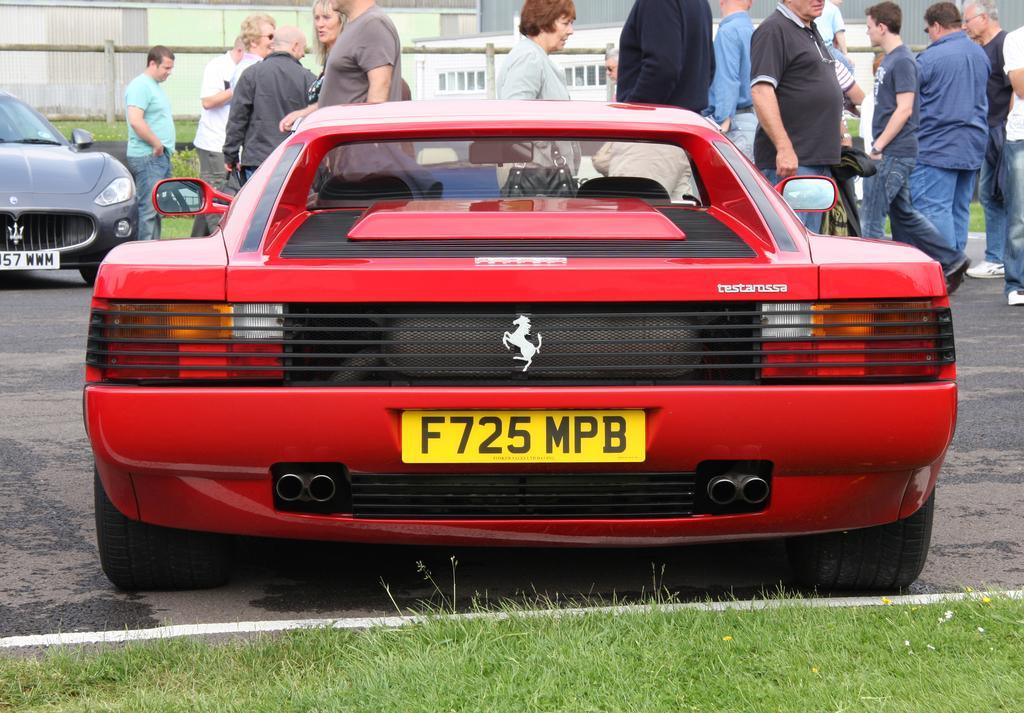In one or two sentences, can you explain what this image depicts? In the foreground of the picture there are car, road and grass. In the center of the picture there are people and car. In the background there are building, railing, plant and grass. 